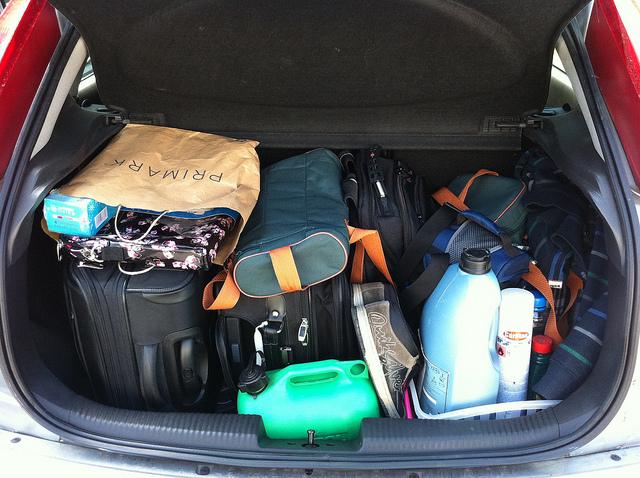What is in the green bottle at the back of the trunk?
Keep it brief. Gas. Is the trunk just about full?
Be succinct. Yes. Where is the driver going?
Answer briefly. Vacation. 